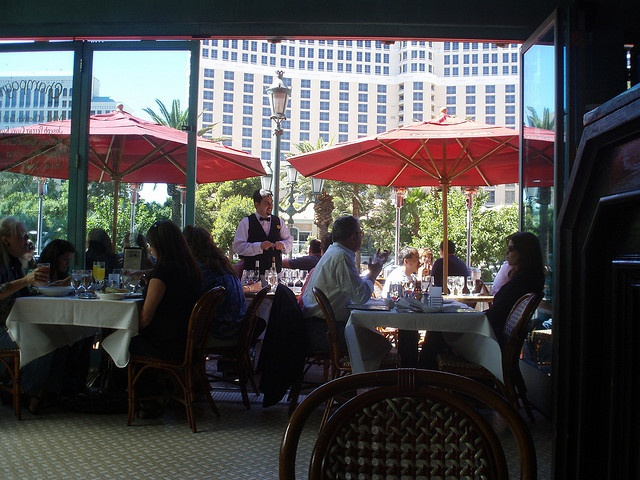Describe the objects in this image and their specific colors. I can see chair in black, purple, and blue tones, umbrella in black, maroon, pink, and brown tones, umbrella in black, brown, white, and maroon tones, people in black, maroon, and gray tones, and dining table in black and gray tones in this image. 